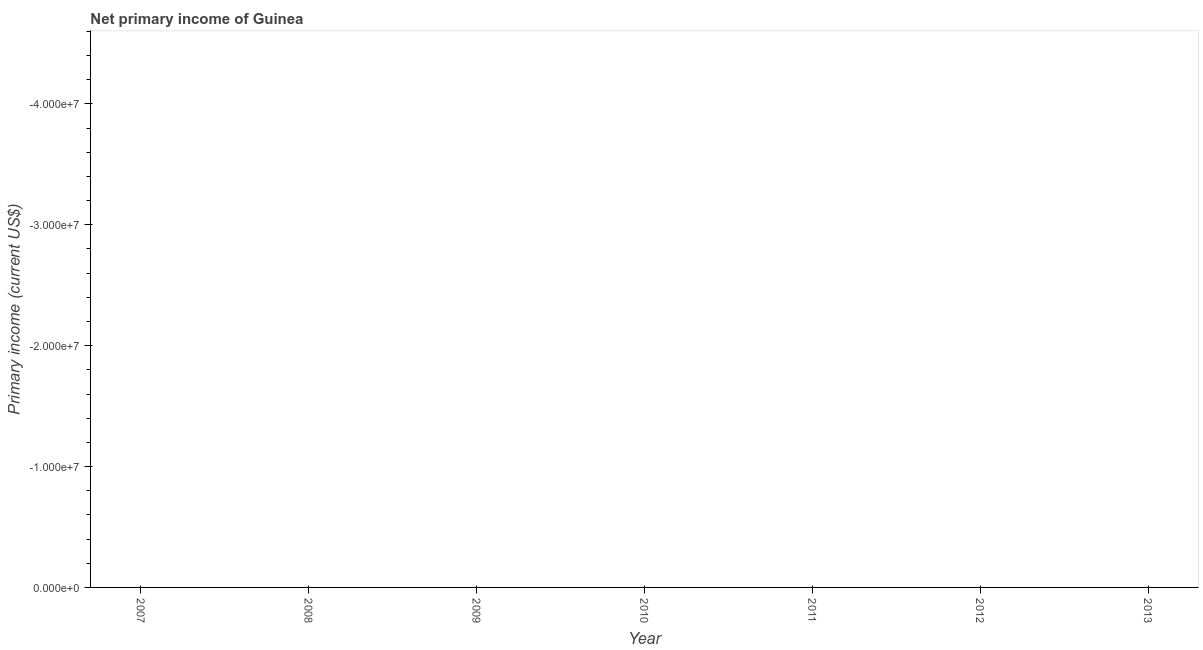What is the amount of primary income in 2012?
Give a very brief answer. 0. Across all years, what is the minimum amount of primary income?
Your answer should be compact. 0. What is the sum of the amount of primary income?
Make the answer very short. 0. What is the median amount of primary income?
Provide a succinct answer. 0. In how many years, is the amount of primary income greater than -8000000 US$?
Your answer should be compact. 0. How many dotlines are there?
Offer a terse response. 0. What is the difference between two consecutive major ticks on the Y-axis?
Make the answer very short. 1.00e+07. What is the title of the graph?
Offer a very short reply. Net primary income of Guinea. What is the label or title of the X-axis?
Offer a terse response. Year. What is the label or title of the Y-axis?
Your answer should be compact. Primary income (current US$). What is the Primary income (current US$) in 2007?
Give a very brief answer. 0. What is the Primary income (current US$) in 2008?
Keep it short and to the point. 0. What is the Primary income (current US$) in 2009?
Offer a terse response. 0. What is the Primary income (current US$) in 2011?
Offer a very short reply. 0. What is the Primary income (current US$) in 2012?
Provide a short and direct response. 0. What is the Primary income (current US$) in 2013?
Your answer should be very brief. 0. 